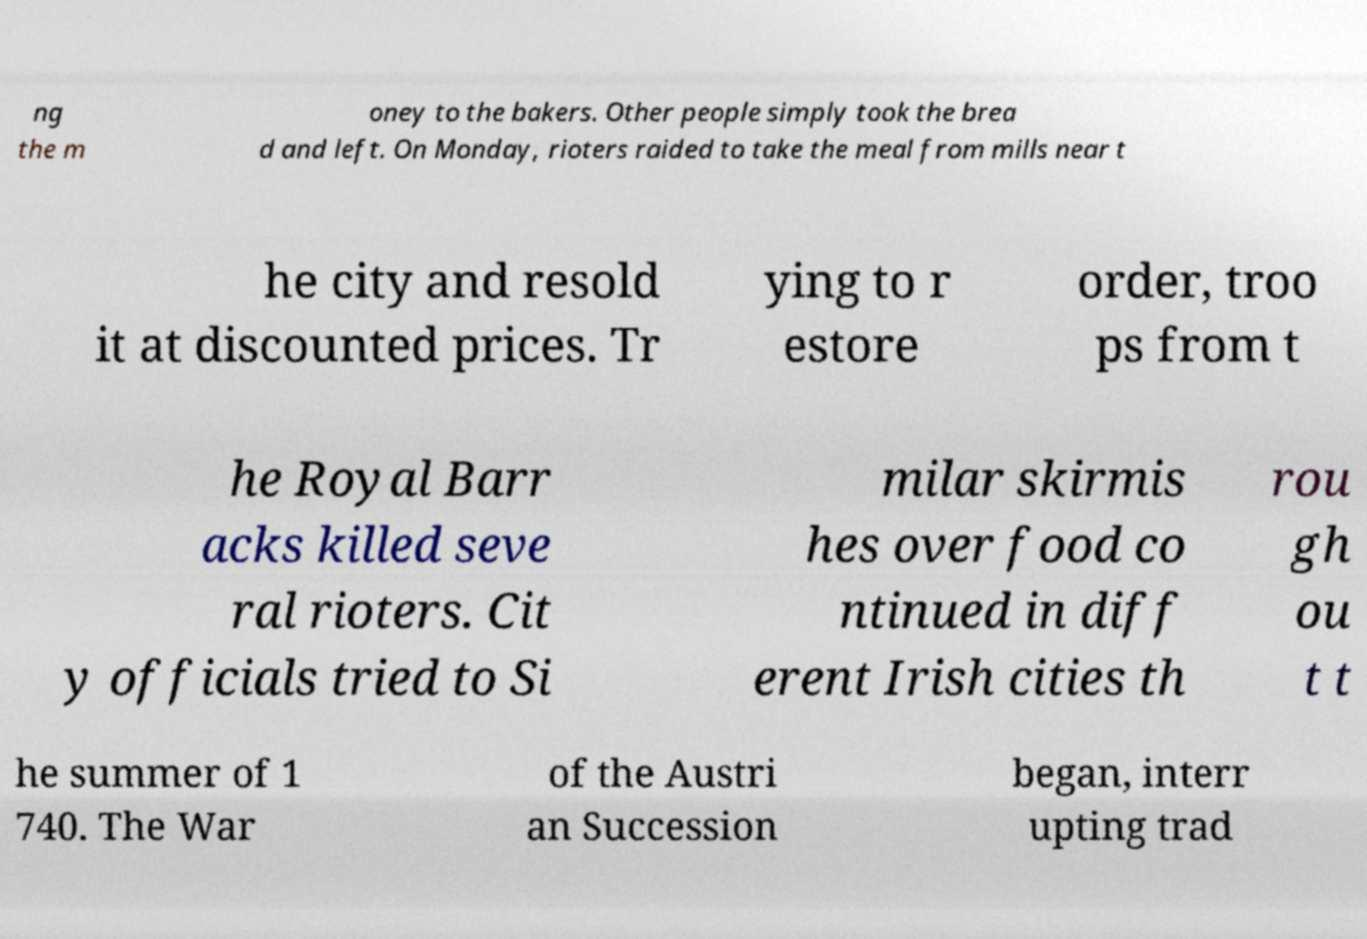What messages or text are displayed in this image? I need them in a readable, typed format. ng the m oney to the bakers. Other people simply took the brea d and left. On Monday, rioters raided to take the meal from mills near t he city and resold it at discounted prices. Tr ying to r estore order, troo ps from t he Royal Barr acks killed seve ral rioters. Cit y officials tried to Si milar skirmis hes over food co ntinued in diff erent Irish cities th rou gh ou t t he summer of 1 740. The War of the Austri an Succession began, interr upting trad 